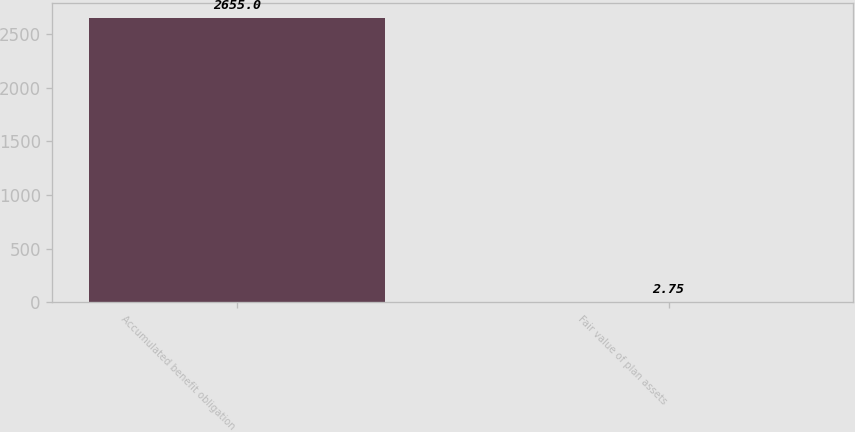Convert chart to OTSL. <chart><loc_0><loc_0><loc_500><loc_500><bar_chart><fcel>Accumulated benefit obligation<fcel>Fair value of plan assets<nl><fcel>2655<fcel>2.75<nl></chart> 